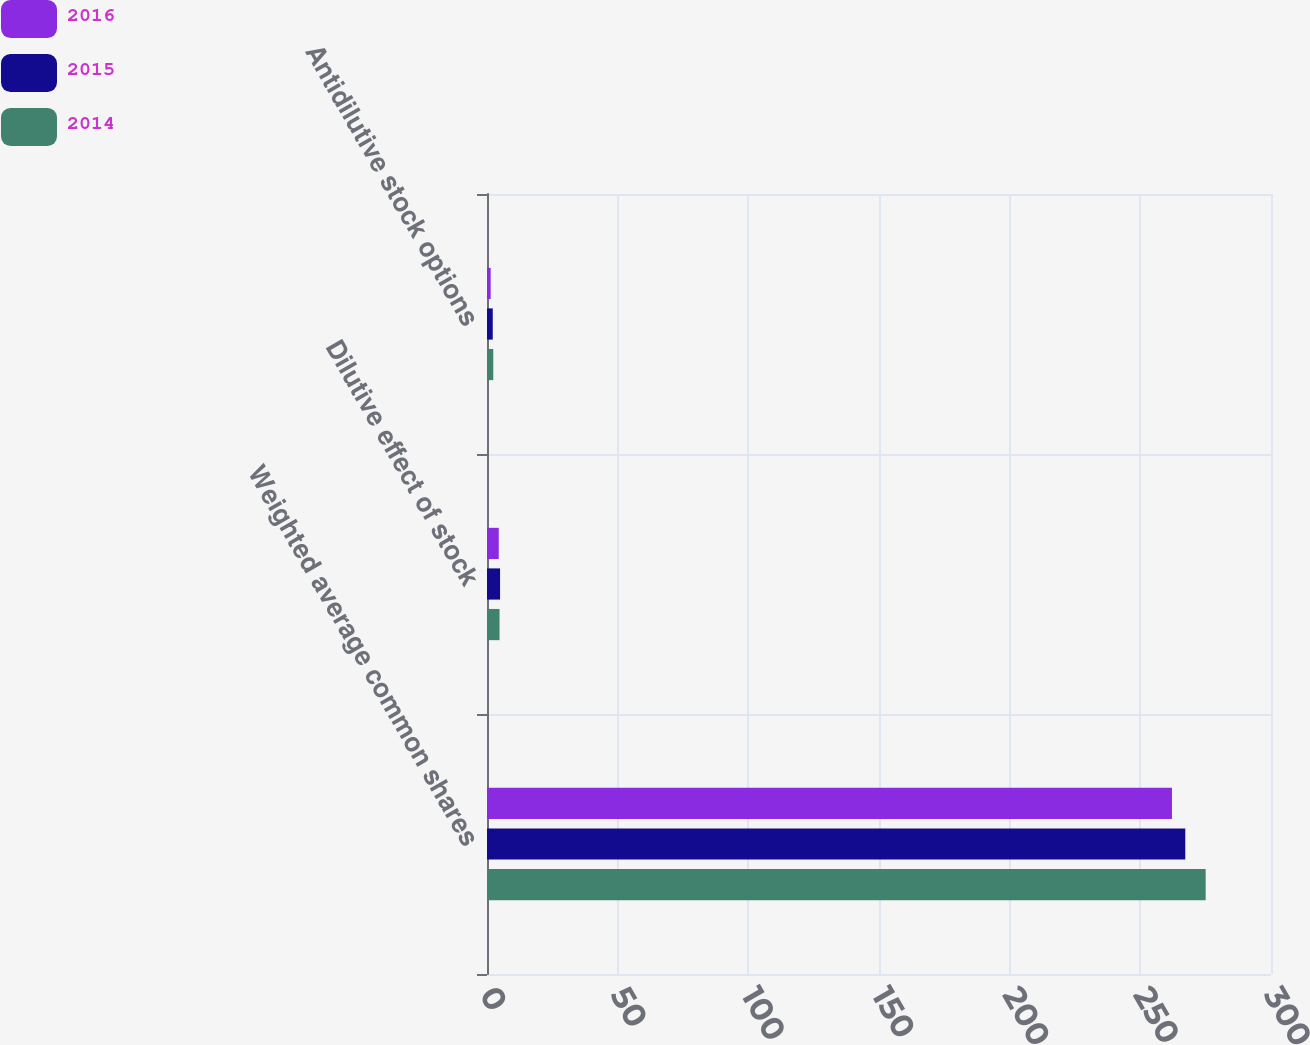Convert chart to OTSL. <chart><loc_0><loc_0><loc_500><loc_500><stacked_bar_chart><ecel><fcel>Weighted average common shares<fcel>Dilutive effect of stock<fcel>Antidilutive stock options<nl><fcel>2016<fcel>262.1<fcel>4.5<fcel>1.4<nl><fcel>2015<fcel>267.2<fcel>5<fcel>2.2<nl><fcel>2014<fcel>275<fcel>4.8<fcel>2.4<nl></chart> 